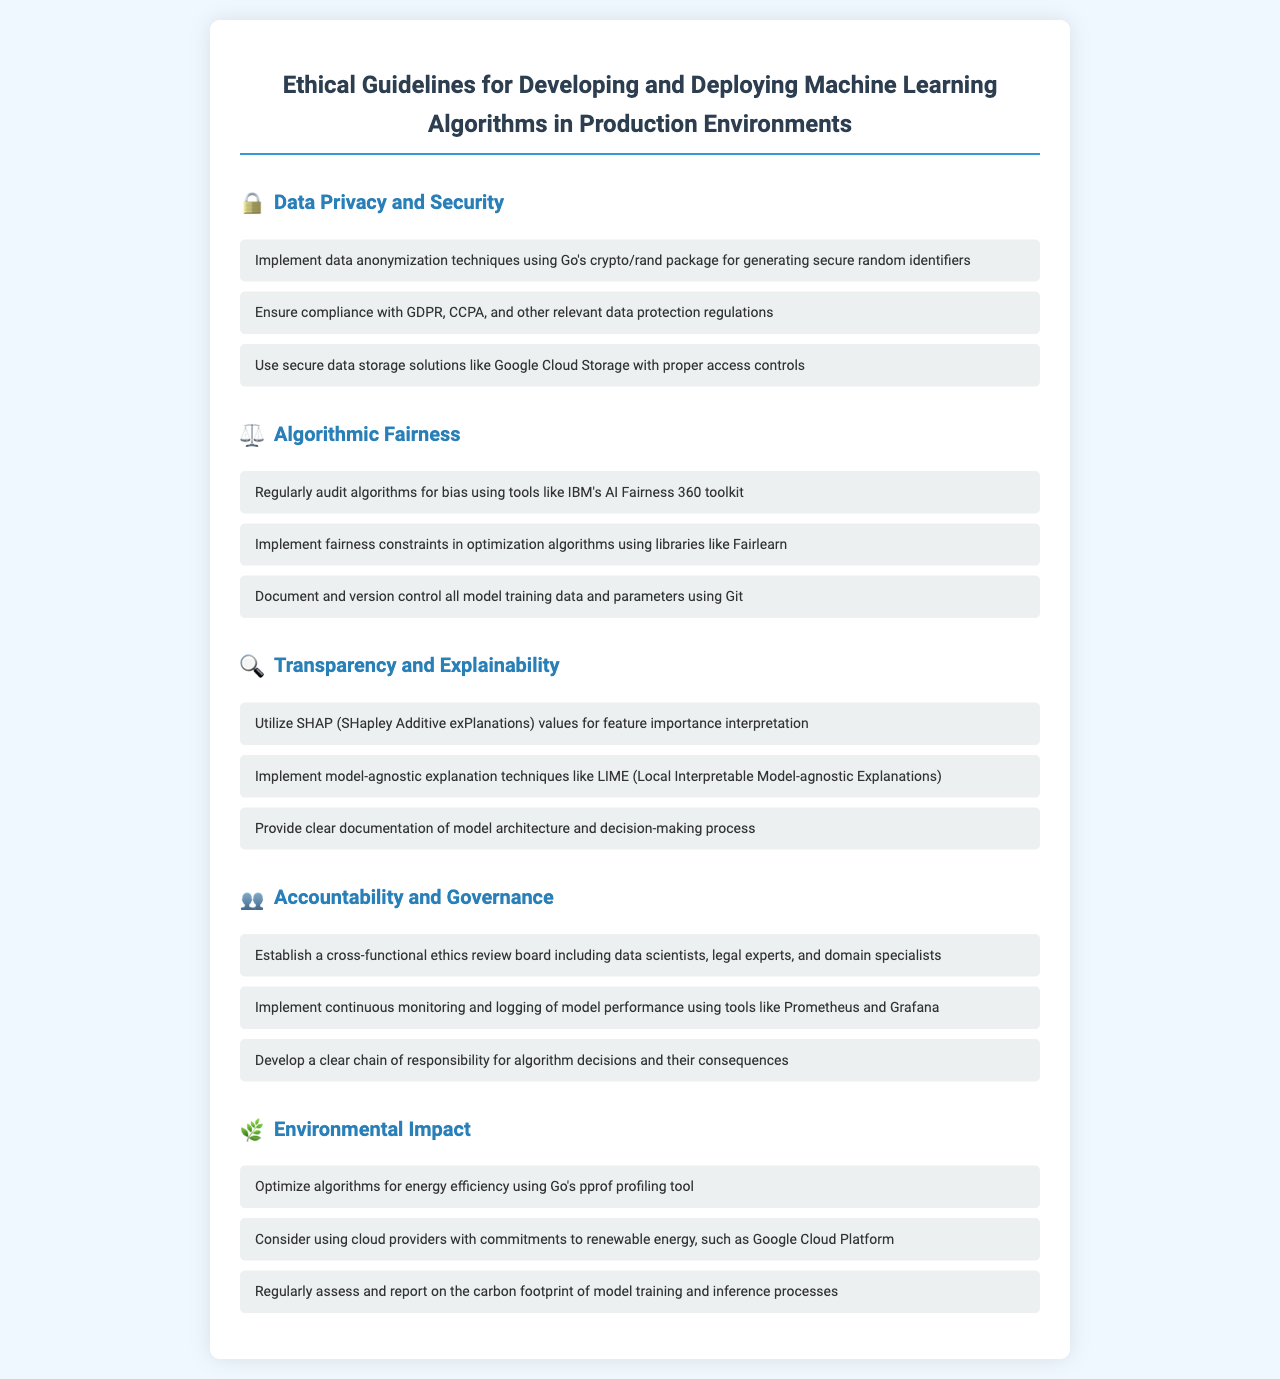What is the title of the document? The title of the document is found in the main heading at the top of the rendered page.
Answer: Ethical Guidelines for Developing and Deploying Machine Learning Algorithms in Production Environments What technique should be used for data anonymization? The document specifies a technique for data anonymization in the "Data Privacy and Security" section.
Answer: Go's crypto/rand package What toolkit is recommended for auditing algorithms for bias? The document mentions a specific toolkit in the "Algorithmic Fairness" section for auditing algorithms.
Answer: IBM's AI Fairness 360 toolkit Which profiling tool is suggested for optimizing algorithms for energy efficiency? The document lists a profiling tool in the "Environmental Impact" section designed for energy optimization.
Answer: Go's pprof What should be established to ensure accountability in algorithm decisions? The document suggests a specific group to be formed in the "Accountability and Governance" section.
Answer: A cross-functional ethics review board Name a model-agnostic explanation technique mentioned in the document. The document includes techniques for explanation in the "Transparency and Explainability" section.
Answer: LIME (Local Interpretable Model-agnostic Explanations) What type of data storage solution is recommended? The document discusses the recommended storage in the "Data Privacy and Security" section.
Answer: Google Cloud Storage Which regulations should be complied with according to the guidelines? The document lists specific data protection regulations in the "Data Privacy and Security" section.
Answer: GDPR, CCPA What is the focus of the "Environmental Impact" section? The focus of the section is hinted through its title.
Answer: Energy efficiency 